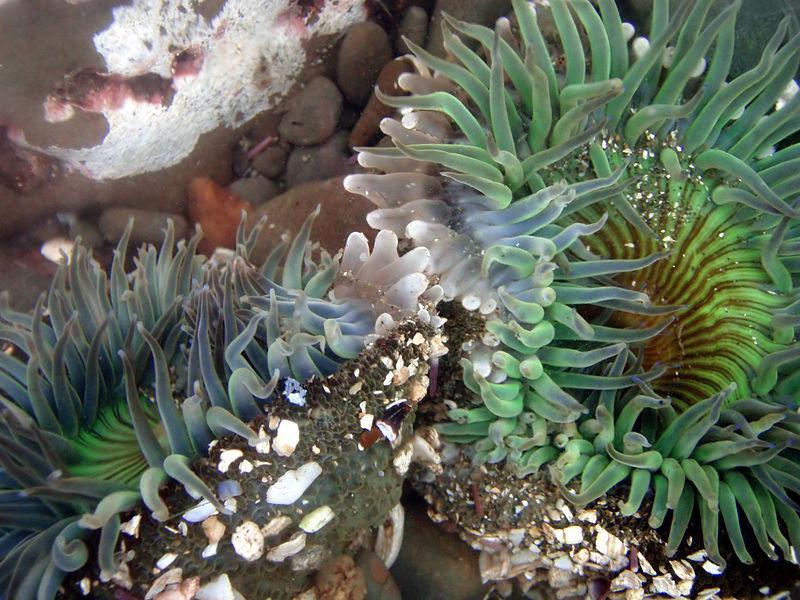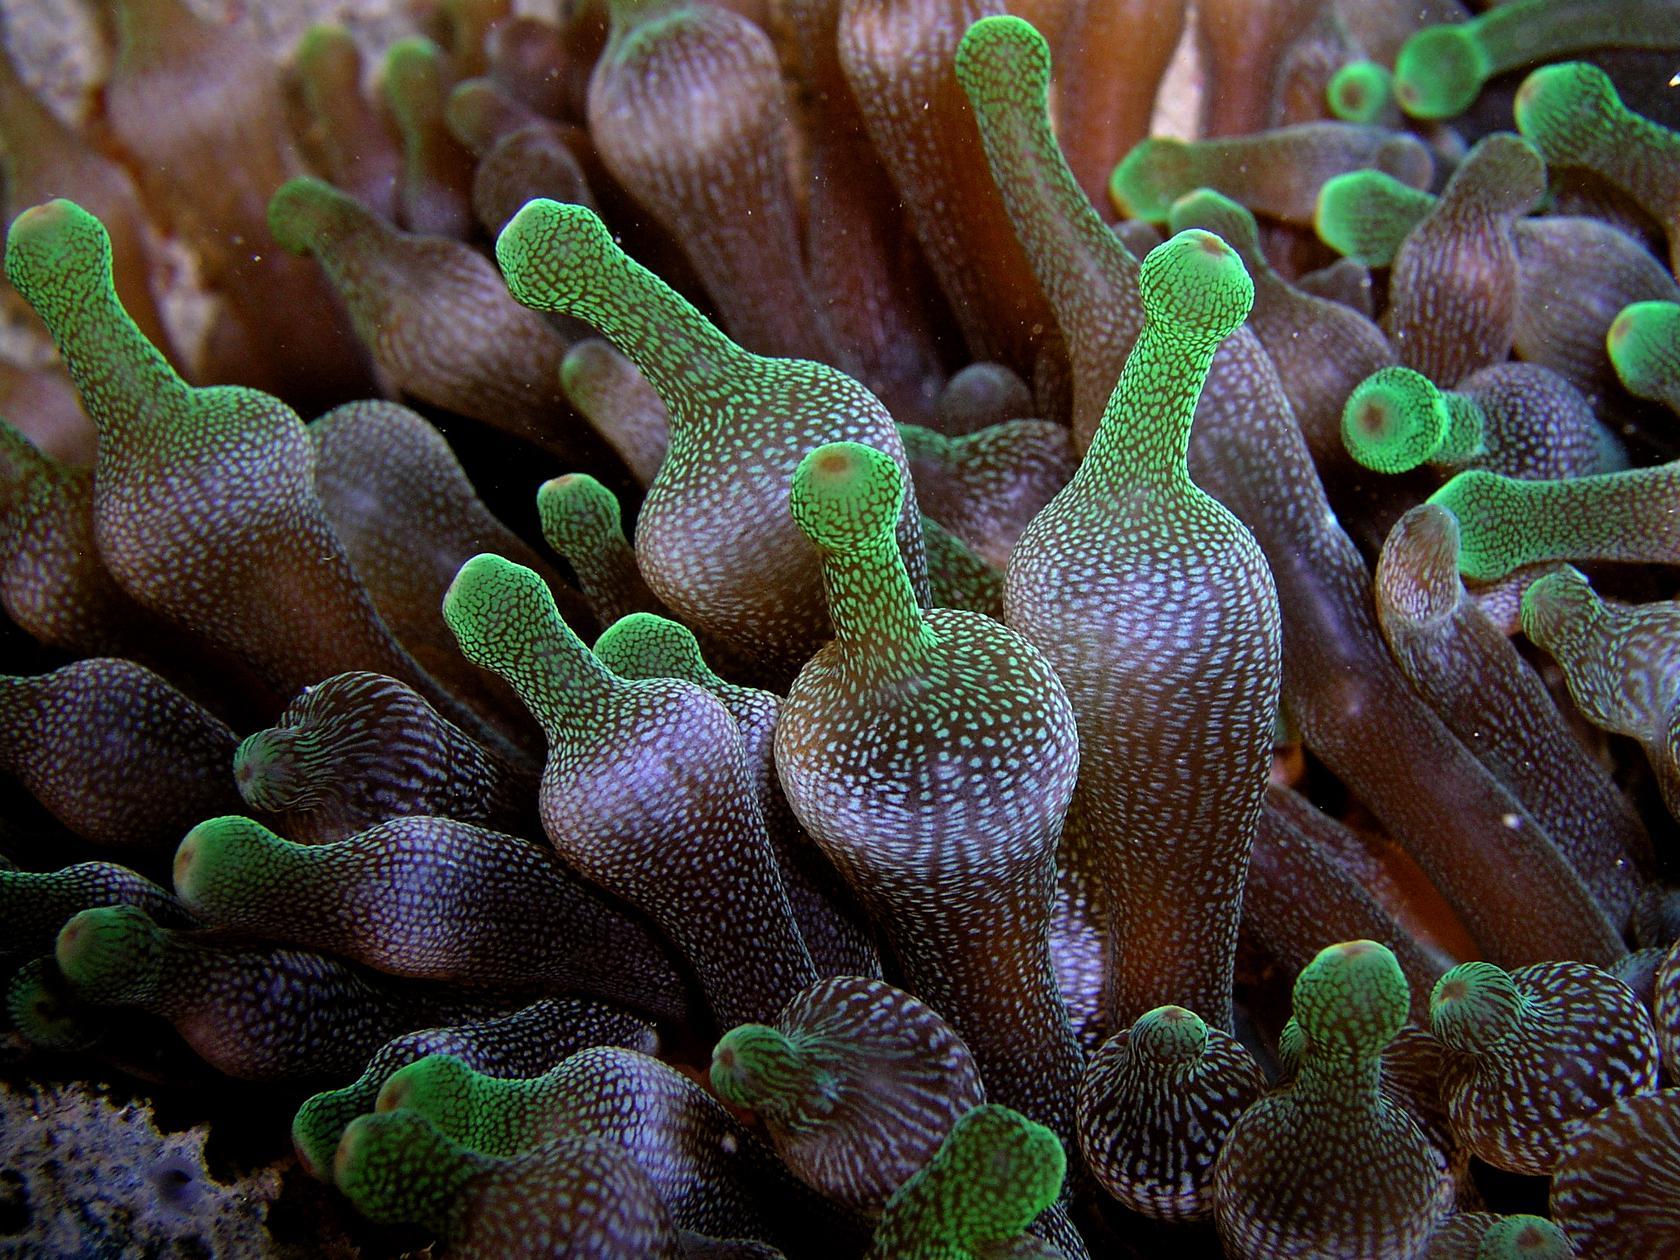The first image is the image on the left, the second image is the image on the right. Assess this claim about the two images: "there are two anemones in each image pair". Correct or not? Answer yes or no. No. 